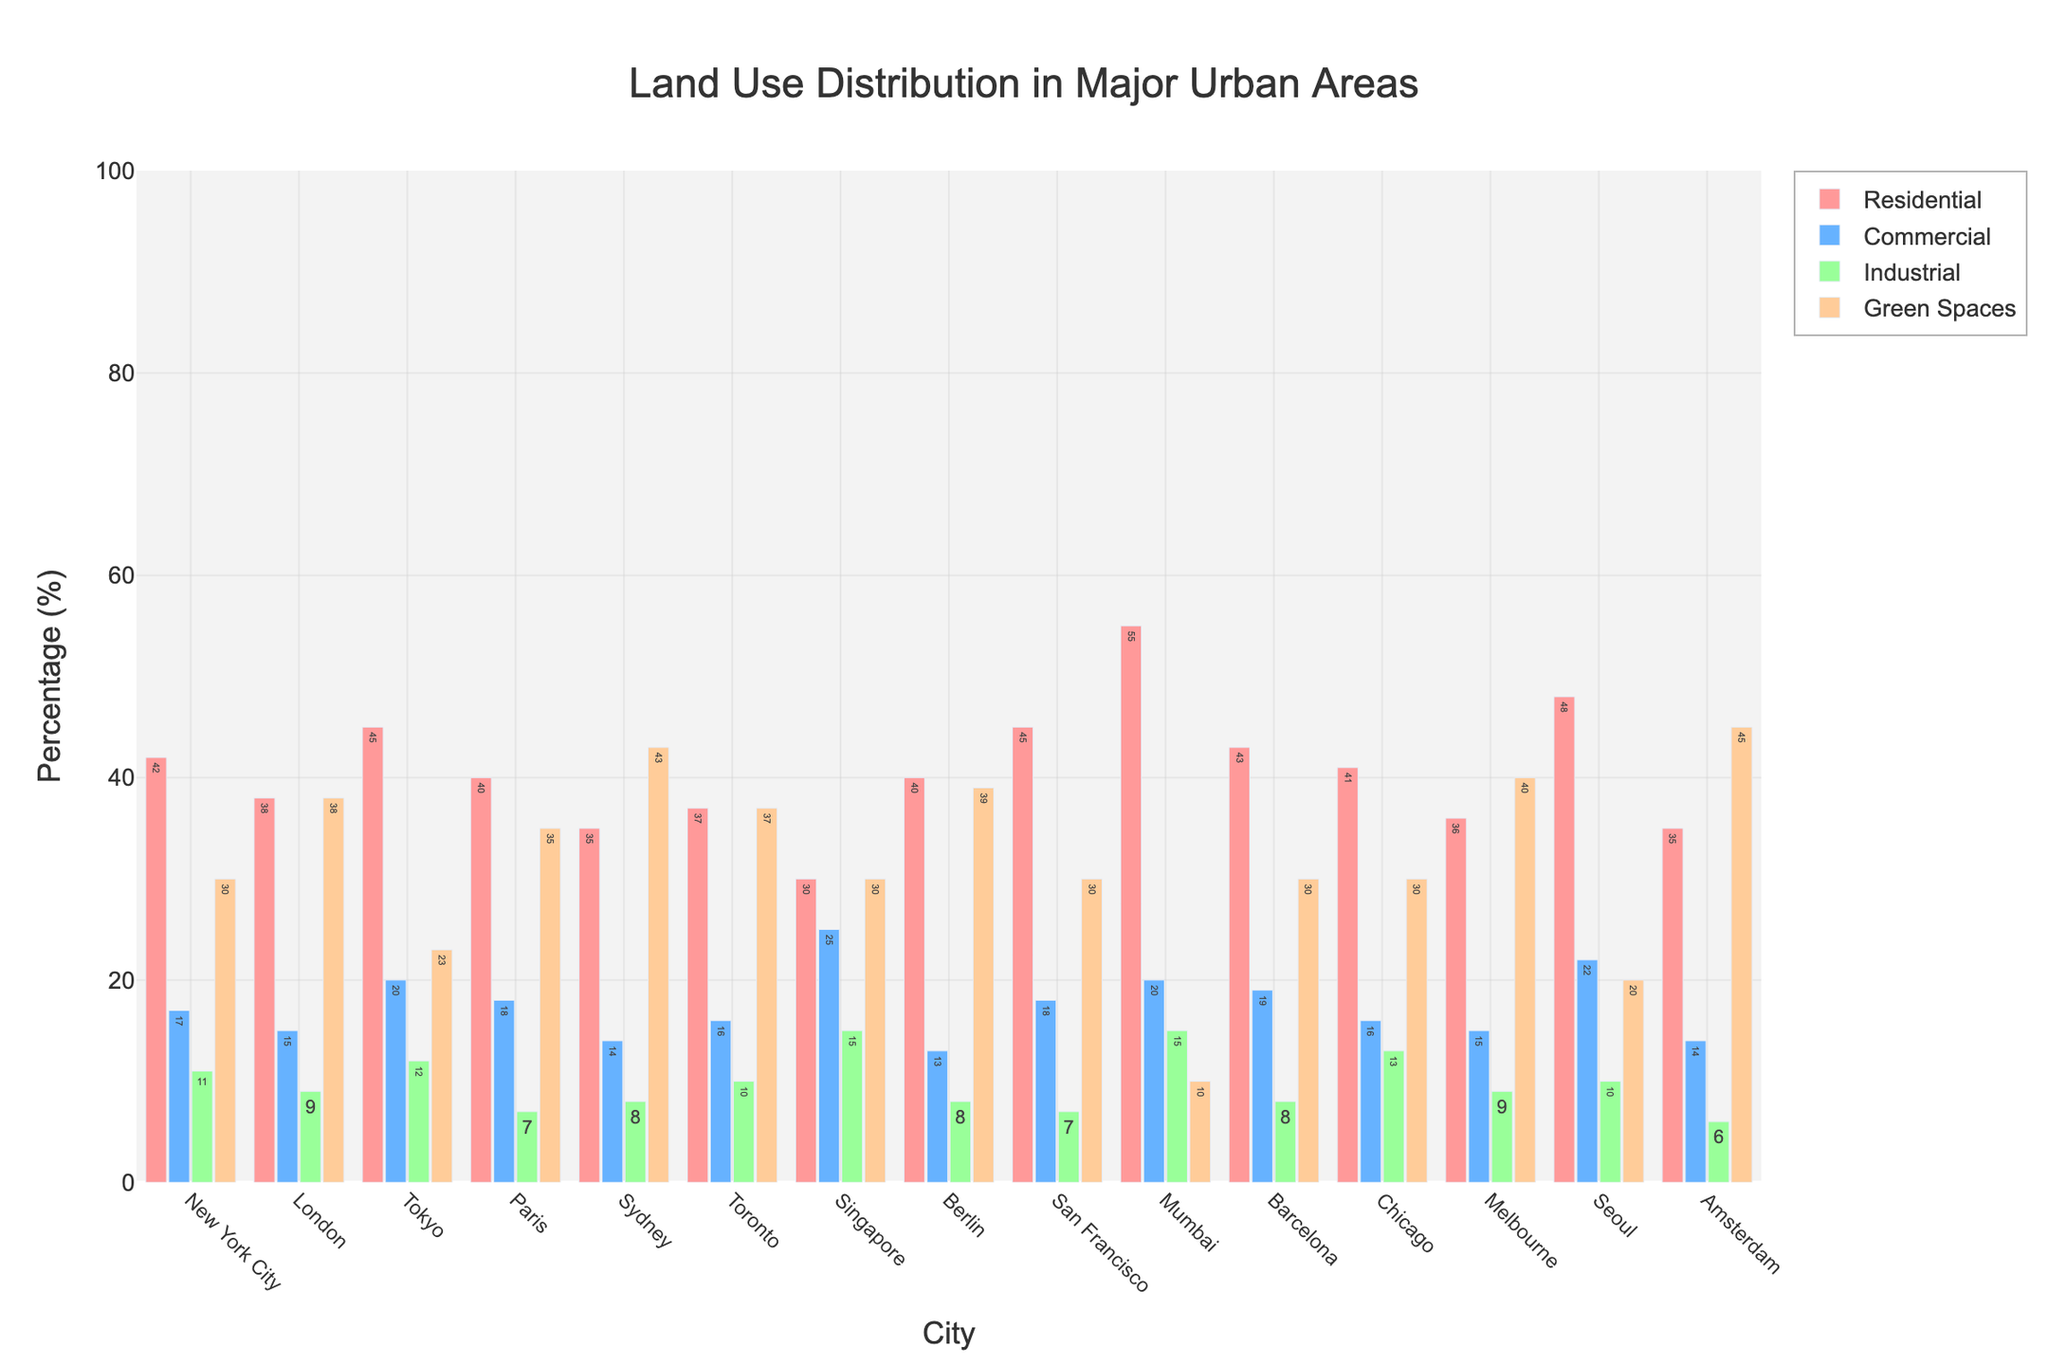What's the city with the highest percentage of residential land use? Locate the bar representing the residential category for each city and check their heights. Mumbai has the tallest bar in the residential category at 55%.
Answer: Mumbai Which city has the lowest percentage of green spaces? Look at the green bars (green spaces) for each city and find the shortest one. Mumbai has the shortest green bar at 10%.
Answer: Mumbai What is the difference in the percentage of industrial land use between New York City and Tokyo? Locate the industrial bars (industrial) for NYC and Tokyo. NYC is at 11% and Tokyo is at 12%. The difference is 12% - 11% = 1%.
Answer: 1% Among Berlin, Amsterdam, and Melbourne, which city has the highest percentage of green spaces? Check and compare the heights of the green space bars for Berlin, Amsterdam, and Melbourne. Amsterdam has the tallest green space bar at 45%.
Answer: Amsterdam What's the sum of the residential and commercial land use percentages for Paris? Locate and add the residential (40%) and commercial (18%) bars for Paris. The sum is 40% + 18% = 58%.
Answer: 58% Which city has a greater percentage of commercial land use, London or Sydney? Compare the heights of the commercial bars (commercial) for London and Sydney. London's commercial bar is at 15%, while Sydney's is at 14%. London has the greater percentage.
Answer: London What's the average percentage of green spaces for New York City, Paris, and Melbourne? Find the green bars for New York City (30%), Paris (35%), and Melbourne (40%). Sum them up and divide by 3. (30 + 35 + 40) / 3 = 35%.
Answer: 35% Which city has the same percentage for residential and green spaces? Look for cities where the heights of the bars for residential and green spaces are equal. New York City and Barcelona both have 30% for residential and green spaces.
Answer: New York City, Barcelona Is the industrial land use of San Francisco greater than that of Paris? Compare the heights of the industrial bars for San Francisco (7%) and Paris (7%). Both have the same percentage, so it is not greater.
Answer: No 